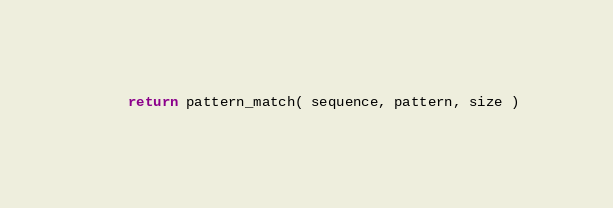<code> <loc_0><loc_0><loc_500><loc_500><_Cython_>    return pattern_match( sequence, pattern, size )
</code> 